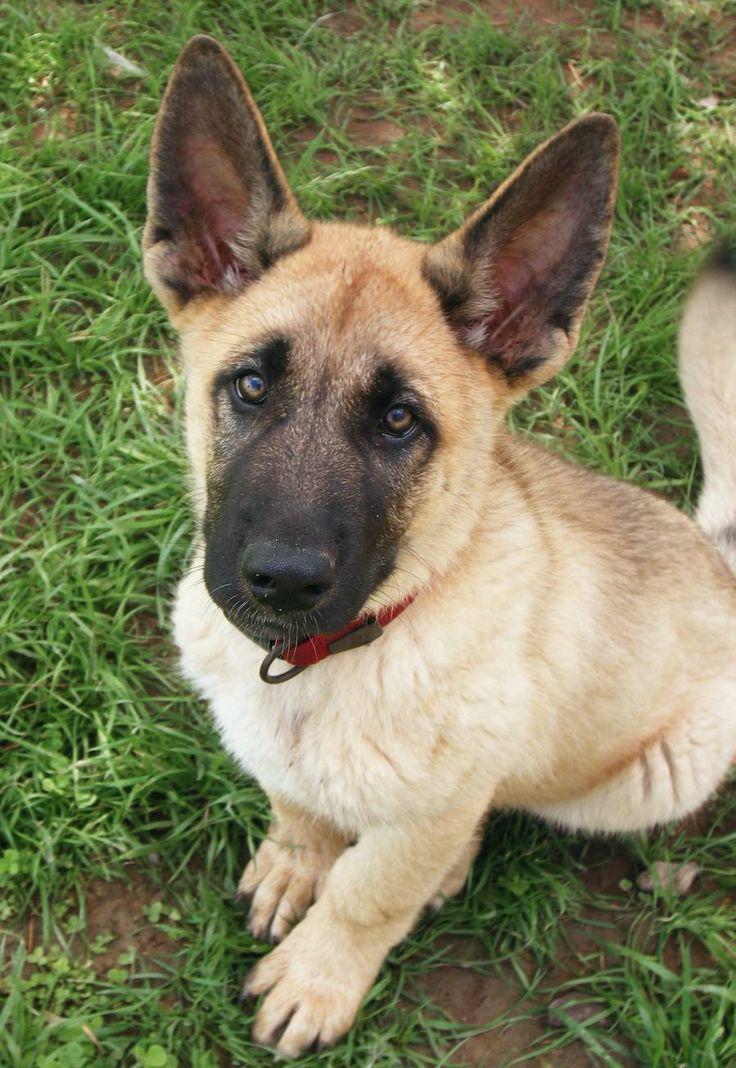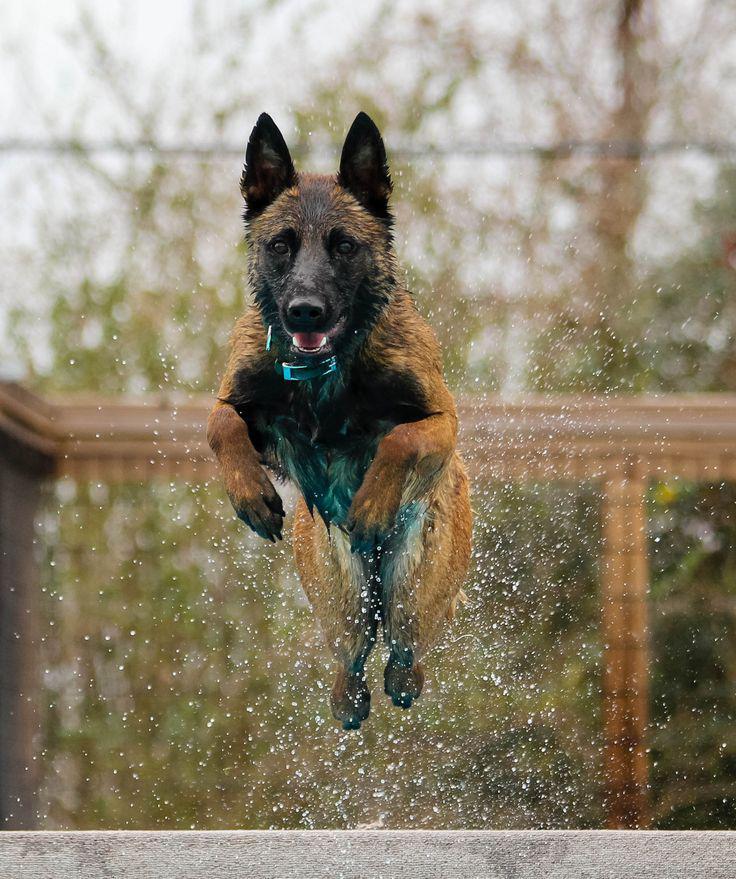The first image is the image on the left, the second image is the image on the right. Considering the images on both sides, is "One dog is lying down." valid? Answer yes or no. No. The first image is the image on the left, the second image is the image on the right. For the images displayed, is the sentence "The right image contains one german shepherd on pavement, looking upward with his head cocked rightward." factually correct? Answer yes or no. No. 